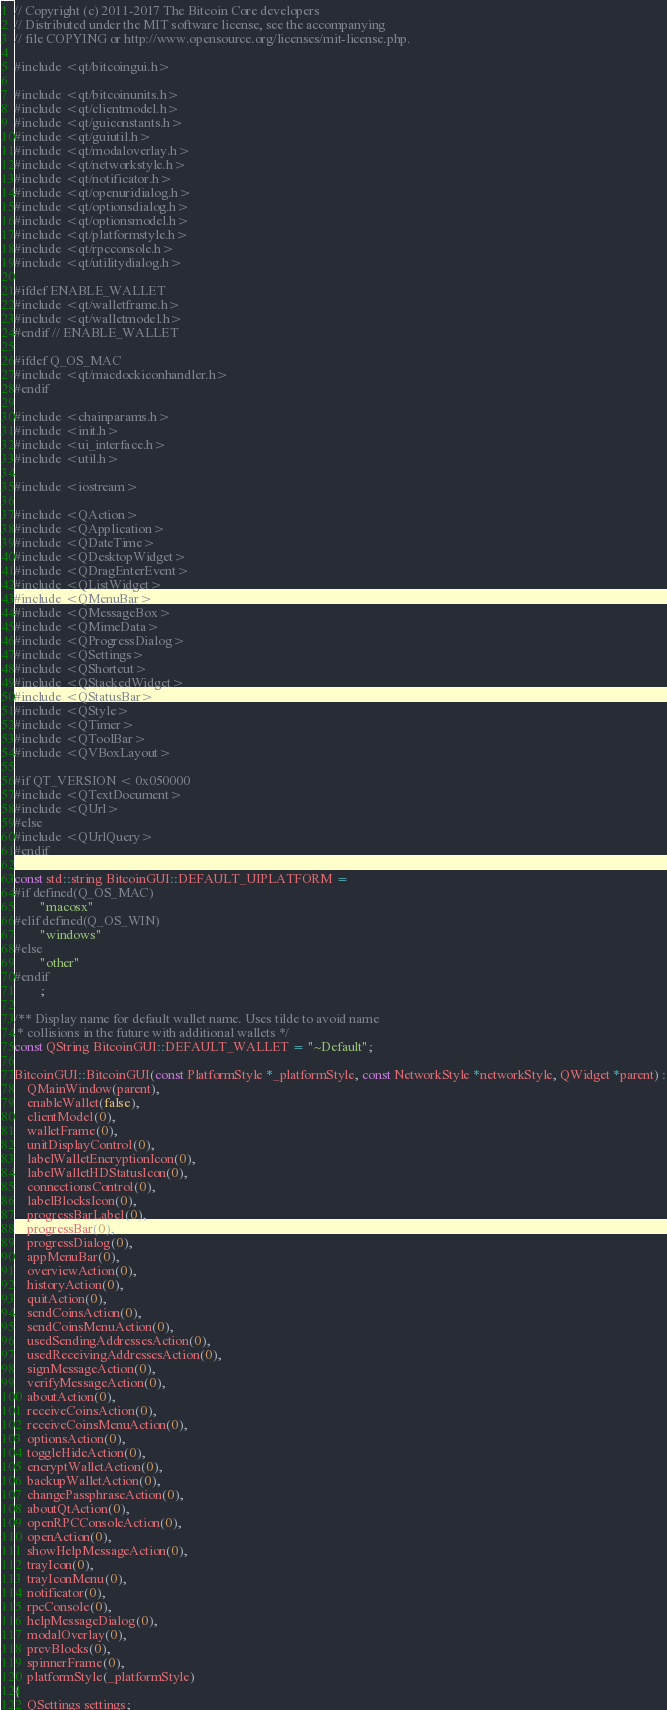Convert code to text. <code><loc_0><loc_0><loc_500><loc_500><_C++_>// Copyright (c) 2011-2017 The Bitcoin Core developers
// Distributed under the MIT software license, see the accompanying
// file COPYING or http://www.opensource.org/licenses/mit-license.php.

#include <qt/bitcoingui.h>

#include <qt/bitcoinunits.h>
#include <qt/clientmodel.h>
#include <qt/guiconstants.h>
#include <qt/guiutil.h>
#include <qt/modaloverlay.h>
#include <qt/networkstyle.h>
#include <qt/notificator.h>
#include <qt/openuridialog.h>
#include <qt/optionsdialog.h>
#include <qt/optionsmodel.h>
#include <qt/platformstyle.h>
#include <qt/rpcconsole.h>
#include <qt/utilitydialog.h>

#ifdef ENABLE_WALLET
#include <qt/walletframe.h>
#include <qt/walletmodel.h>
#endif // ENABLE_WALLET

#ifdef Q_OS_MAC
#include <qt/macdockiconhandler.h>
#endif

#include <chainparams.h>
#include <init.h>
#include <ui_interface.h>
#include <util.h>

#include <iostream>

#include <QAction>
#include <QApplication>
#include <QDateTime>
#include <QDesktopWidget>
#include <QDragEnterEvent>
#include <QListWidget>
#include <QMenuBar>
#include <QMessageBox>
#include <QMimeData>
#include <QProgressDialog>
#include <QSettings>
#include <QShortcut>
#include <QStackedWidget>
#include <QStatusBar>
#include <QStyle>
#include <QTimer>
#include <QToolBar>
#include <QVBoxLayout>

#if QT_VERSION < 0x050000
#include <QTextDocument>
#include <QUrl>
#else
#include <QUrlQuery>
#endif

const std::string BitcoinGUI::DEFAULT_UIPLATFORM =
#if defined(Q_OS_MAC)
        "macosx"
#elif defined(Q_OS_WIN)
        "windows"
#else
        "other"
#endif
        ;

/** Display name for default wallet name. Uses tilde to avoid name
 * collisions in the future with additional wallets */
const QString BitcoinGUI::DEFAULT_WALLET = "~Default";

BitcoinGUI::BitcoinGUI(const PlatformStyle *_platformStyle, const NetworkStyle *networkStyle, QWidget *parent) :
    QMainWindow(parent),
    enableWallet(false),
    clientModel(0),
    walletFrame(0),
    unitDisplayControl(0),
    labelWalletEncryptionIcon(0),
    labelWalletHDStatusIcon(0),
    connectionsControl(0),
    labelBlocksIcon(0),
    progressBarLabel(0),
    progressBar(0),
    progressDialog(0),
    appMenuBar(0),
    overviewAction(0),
    historyAction(0),
    quitAction(0),
    sendCoinsAction(0),
    sendCoinsMenuAction(0),
    usedSendingAddressesAction(0),
    usedReceivingAddressesAction(0),
    signMessageAction(0),
    verifyMessageAction(0),
    aboutAction(0),
    receiveCoinsAction(0),
    receiveCoinsMenuAction(0),
    optionsAction(0),
    toggleHideAction(0),
    encryptWalletAction(0),
    backupWalletAction(0),
    changePassphraseAction(0),
    aboutQtAction(0),
    openRPCConsoleAction(0),
    openAction(0),
    showHelpMessageAction(0),
    trayIcon(0),
    trayIconMenu(0),
    notificator(0),
    rpcConsole(0),
    helpMessageDialog(0),
    modalOverlay(0),
    prevBlocks(0),
    spinnerFrame(0),
    platformStyle(_platformStyle)
{
    QSettings settings;</code> 